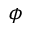<formula> <loc_0><loc_0><loc_500><loc_500>\phi</formula> 